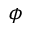<formula> <loc_0><loc_0><loc_500><loc_500>\phi</formula> 